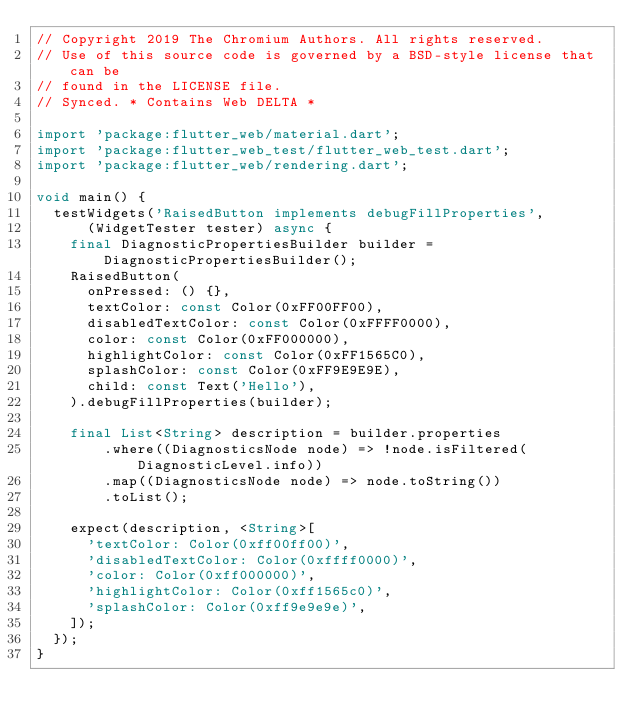<code> <loc_0><loc_0><loc_500><loc_500><_Dart_>// Copyright 2019 The Chromium Authors. All rights reserved.
// Use of this source code is governed by a BSD-style license that can be
// found in the LICENSE file.
// Synced. * Contains Web DELTA *

import 'package:flutter_web/material.dart';
import 'package:flutter_web_test/flutter_web_test.dart';
import 'package:flutter_web/rendering.dart';

void main() {
  testWidgets('RaisedButton implements debugFillProperties',
      (WidgetTester tester) async {
    final DiagnosticPropertiesBuilder builder = DiagnosticPropertiesBuilder();
    RaisedButton(
      onPressed: () {},
      textColor: const Color(0xFF00FF00),
      disabledTextColor: const Color(0xFFFF0000),
      color: const Color(0xFF000000),
      highlightColor: const Color(0xFF1565C0),
      splashColor: const Color(0xFF9E9E9E),
      child: const Text('Hello'),
    ).debugFillProperties(builder);

    final List<String> description = builder.properties
        .where((DiagnosticsNode node) => !node.isFiltered(DiagnosticLevel.info))
        .map((DiagnosticsNode node) => node.toString())
        .toList();

    expect(description, <String>[
      'textColor: Color(0xff00ff00)',
      'disabledTextColor: Color(0xffff0000)',
      'color: Color(0xff000000)',
      'highlightColor: Color(0xff1565c0)',
      'splashColor: Color(0xff9e9e9e)',
    ]);
  });
}
</code> 